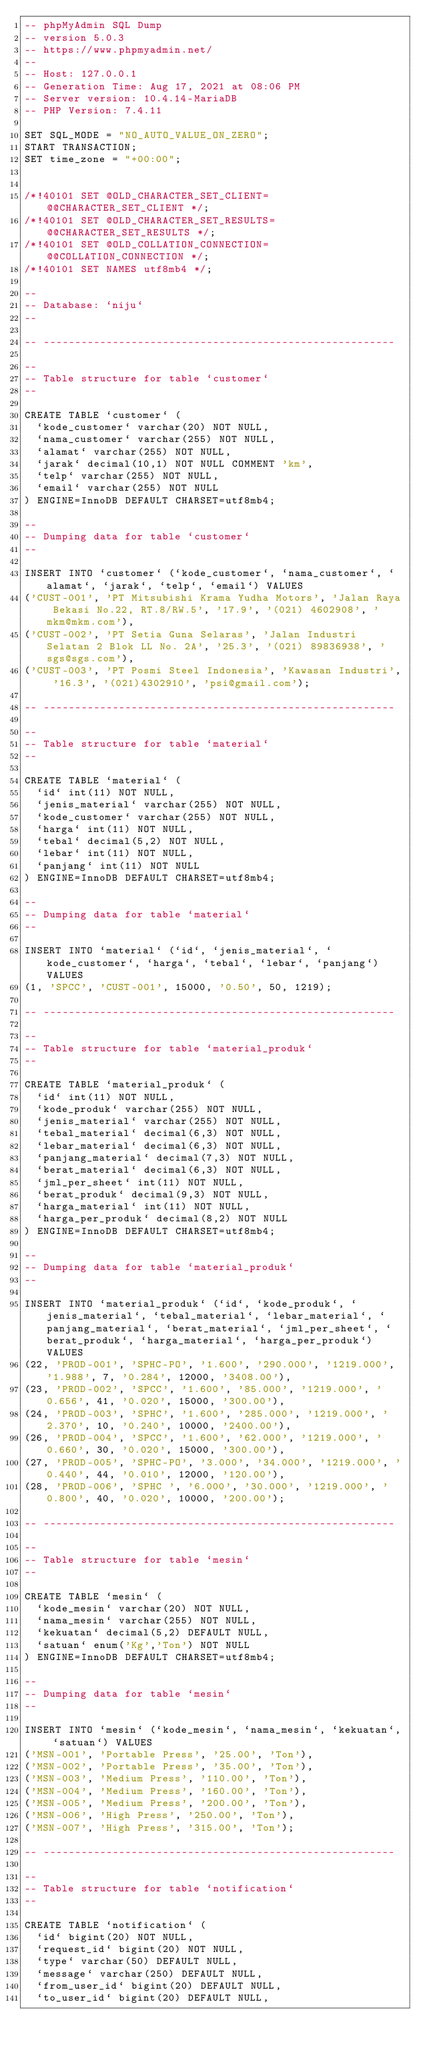<code> <loc_0><loc_0><loc_500><loc_500><_SQL_>-- phpMyAdmin SQL Dump
-- version 5.0.3
-- https://www.phpmyadmin.net/
--
-- Host: 127.0.0.1
-- Generation Time: Aug 17, 2021 at 08:06 PM
-- Server version: 10.4.14-MariaDB
-- PHP Version: 7.4.11

SET SQL_MODE = "NO_AUTO_VALUE_ON_ZERO";
START TRANSACTION;
SET time_zone = "+00:00";


/*!40101 SET @OLD_CHARACTER_SET_CLIENT=@@CHARACTER_SET_CLIENT */;
/*!40101 SET @OLD_CHARACTER_SET_RESULTS=@@CHARACTER_SET_RESULTS */;
/*!40101 SET @OLD_COLLATION_CONNECTION=@@COLLATION_CONNECTION */;
/*!40101 SET NAMES utf8mb4 */;

--
-- Database: `niju`
--

-- --------------------------------------------------------

--
-- Table structure for table `customer`
--

CREATE TABLE `customer` (
  `kode_customer` varchar(20) NOT NULL,
  `nama_customer` varchar(255) NOT NULL,
  `alamat` varchar(255) NOT NULL,
  `jarak` decimal(10,1) NOT NULL COMMENT 'km',
  `telp` varchar(255) NOT NULL,
  `email` varchar(255) NOT NULL
) ENGINE=InnoDB DEFAULT CHARSET=utf8mb4;

--
-- Dumping data for table `customer`
--

INSERT INTO `customer` (`kode_customer`, `nama_customer`, `alamat`, `jarak`, `telp`, `email`) VALUES
('CUST-001', 'PT Mitsubishi Krama Yudha Motors', 'Jalan Raya Bekasi No.22, RT.8/RW.5', '17.9', '(021) 4602908', 'mkm@mkm.com'),
('CUST-002', 'PT Setia Guna Selaras', 'Jalan Industri Selatan 2 Blok LL No. 2A', '25.3', '(021) 89836938', 'sgs@sgs.com'),
('CUST-003', 'PT Posmi Steel Indonesia', 'Kawasan Industri', '16.3', '(021)4302910', 'psi@gmail.com');

-- --------------------------------------------------------

--
-- Table structure for table `material`
--

CREATE TABLE `material` (
  `id` int(11) NOT NULL,
  `jenis_material` varchar(255) NOT NULL,
  `kode_customer` varchar(255) NOT NULL,
  `harga` int(11) NOT NULL,
  `tebal` decimal(5,2) NOT NULL,
  `lebar` int(11) NOT NULL,
  `panjang` int(11) NOT NULL
) ENGINE=InnoDB DEFAULT CHARSET=utf8mb4;

--
-- Dumping data for table `material`
--

INSERT INTO `material` (`id`, `jenis_material`, `kode_customer`, `harga`, `tebal`, `lebar`, `panjang`) VALUES
(1, 'SPCC', 'CUST-001', 15000, '0.50', 50, 1219);

-- --------------------------------------------------------

--
-- Table structure for table `material_produk`
--

CREATE TABLE `material_produk` (
  `id` int(11) NOT NULL,
  `kode_produk` varchar(255) NOT NULL,
  `jenis_material` varchar(255) NOT NULL,
  `tebal_material` decimal(6,3) NOT NULL,
  `lebar_material` decimal(6,3) NOT NULL,
  `panjang_material` decimal(7,3) NOT NULL,
  `berat_material` decimal(6,3) NOT NULL,
  `jml_per_sheet` int(11) NOT NULL,
  `berat_produk` decimal(9,3) NOT NULL,
  `harga_material` int(11) NOT NULL,
  `harga_per_produk` decimal(8,2) NOT NULL
) ENGINE=InnoDB DEFAULT CHARSET=utf8mb4;

--
-- Dumping data for table `material_produk`
--

INSERT INTO `material_produk` (`id`, `kode_produk`, `jenis_material`, `tebal_material`, `lebar_material`, `panjang_material`, `berat_material`, `jml_per_sheet`, `berat_produk`, `harga_material`, `harga_per_produk`) VALUES
(22, 'PROD-001', 'SPHC-PO', '1.600', '290.000', '1219.000', '1.988', 7, '0.284', 12000, '3408.00'),
(23, 'PROD-002', 'SPCC', '1.600', '85.000', '1219.000', '0.656', 41, '0.020', 15000, '300.00'),
(24, 'PROD-003', 'SPHC', '1.600', '285.000', '1219.000', '2.370', 10, '0.240', 10000, '2400.00'),
(26, 'PROD-004', 'SPCC', '1.600', '62.000', '1219.000', '0.660', 30, '0.020', 15000, '300.00'),
(27, 'PROD-005', 'SPHC-PO', '3.000', '34.000', '1219.000', '0.440', 44, '0.010', 12000, '120.00'),
(28, 'PROD-006', 'SPHC ', '6.000', '30.000', '1219.000', '0.800', 40, '0.020', 10000, '200.00');

-- --------------------------------------------------------

--
-- Table structure for table `mesin`
--

CREATE TABLE `mesin` (
  `kode_mesin` varchar(20) NOT NULL,
  `nama_mesin` varchar(255) NOT NULL,
  `kekuatan` decimal(5,2) DEFAULT NULL,
  `satuan` enum('Kg','Ton') NOT NULL
) ENGINE=InnoDB DEFAULT CHARSET=utf8mb4;

--
-- Dumping data for table `mesin`
--

INSERT INTO `mesin` (`kode_mesin`, `nama_mesin`, `kekuatan`, `satuan`) VALUES
('MSN-001', 'Portable Press', '25.00', 'Ton'),
('MSN-002', 'Portable Press', '35.00', 'Ton'),
('MSN-003', 'Medium Press', '110.00', 'Ton'),
('MSN-004', 'Medium Press', '160.00', 'Ton'),
('MSN-005', 'Medium Press', '200.00', 'Ton'),
('MSN-006', 'High Press', '250.00', 'Ton'),
('MSN-007', 'High Press', '315.00', 'Ton');

-- --------------------------------------------------------

--
-- Table structure for table `notification`
--

CREATE TABLE `notification` (
  `id` bigint(20) NOT NULL,
  `request_id` bigint(20) NOT NULL,
  `type` varchar(50) DEFAULT NULL,
  `message` varchar(250) DEFAULT NULL,
  `from_user_id` bigint(20) DEFAULT NULL,
  `to_user_id` bigint(20) DEFAULT NULL,</code> 